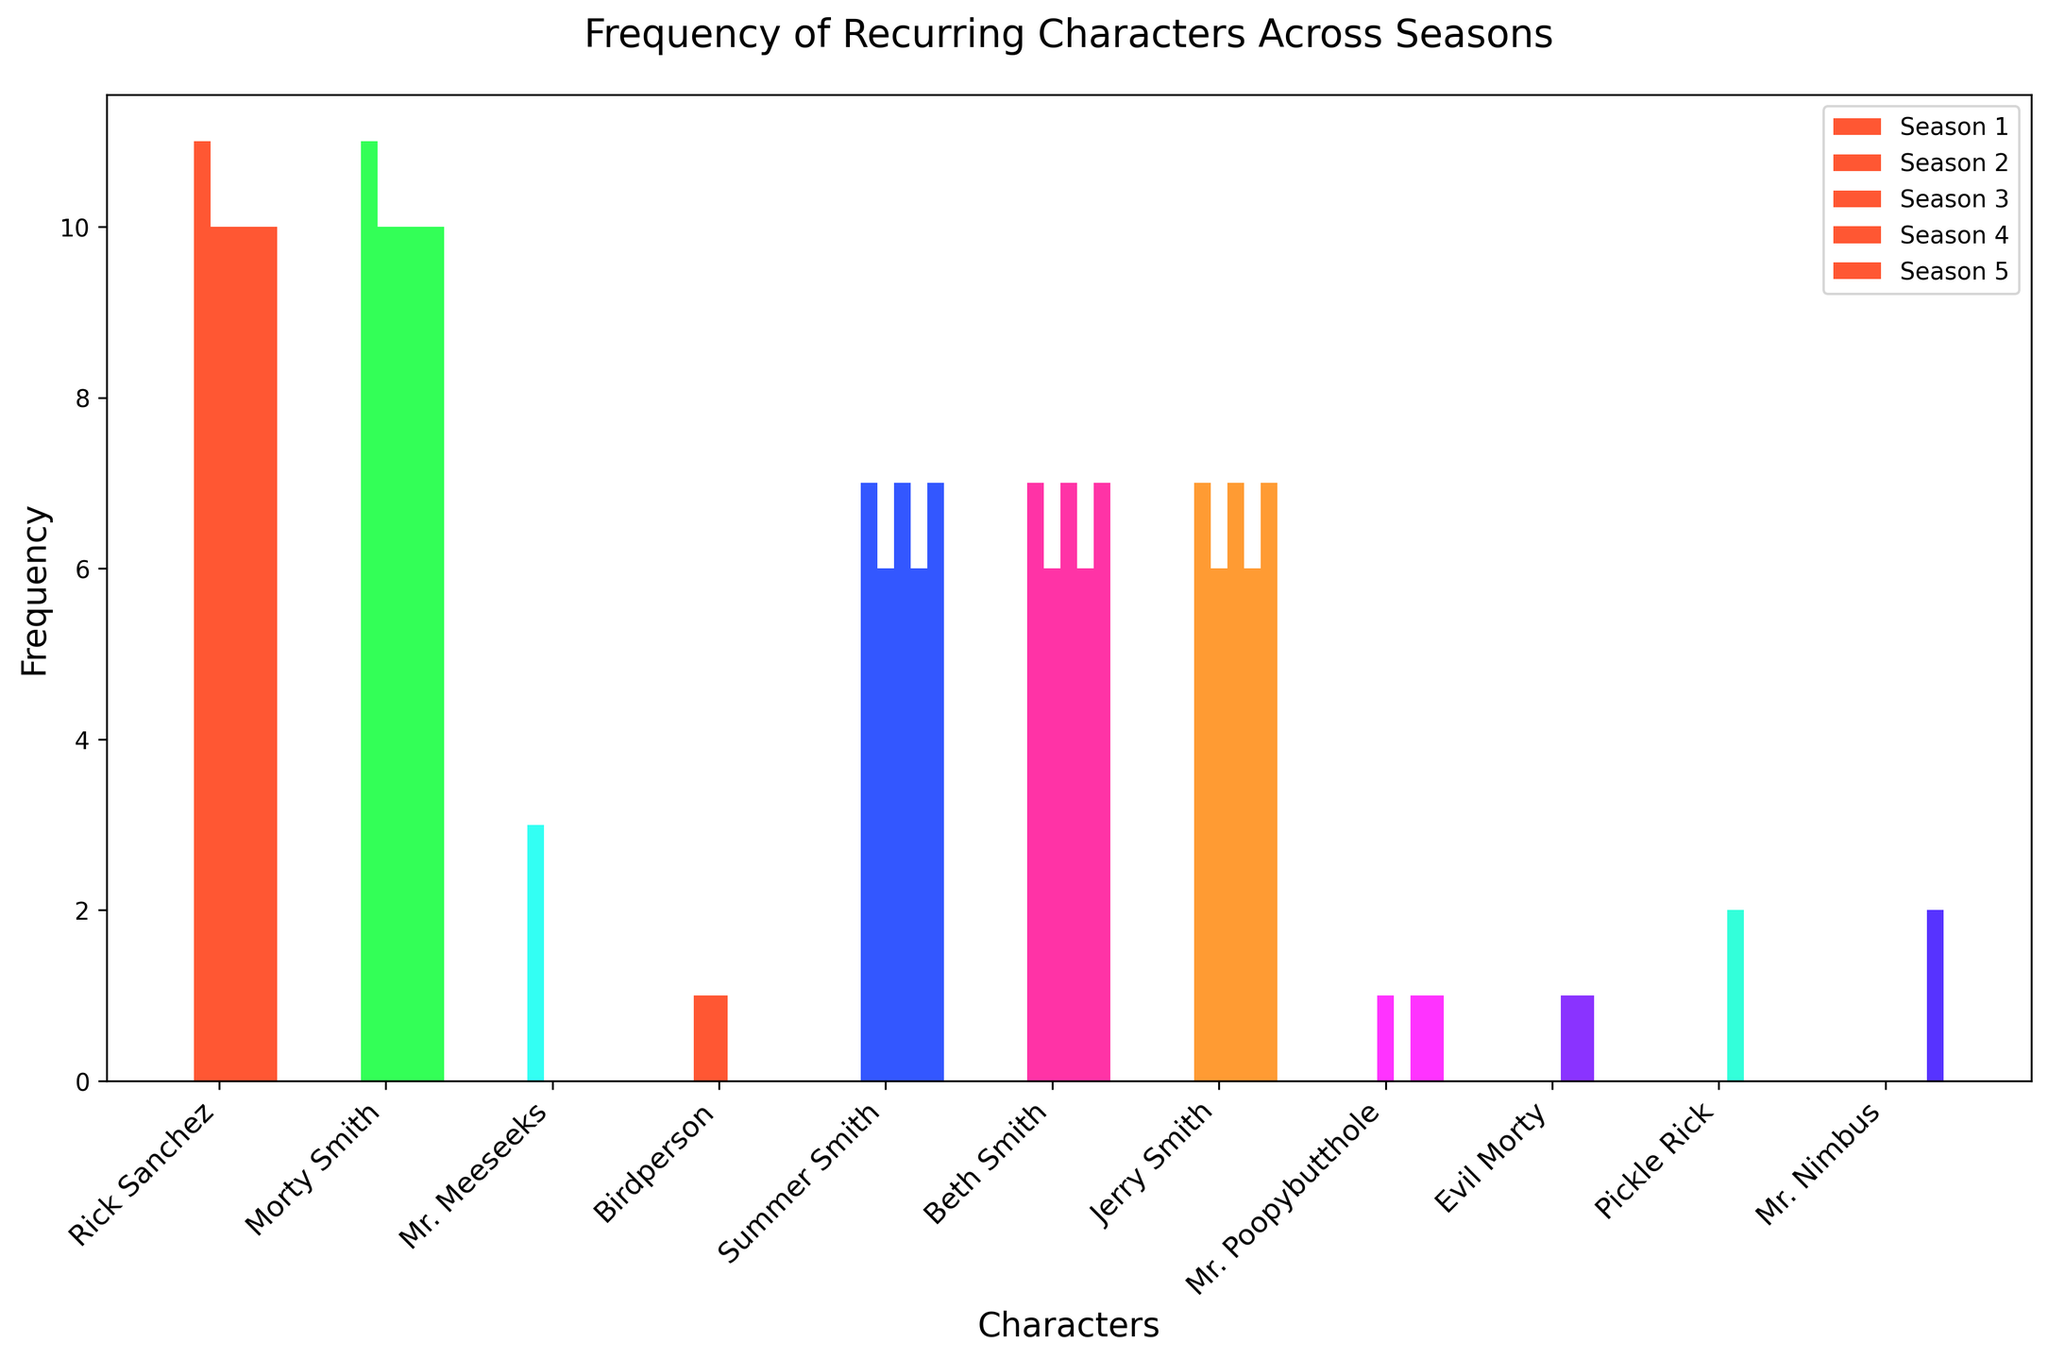Which character appears the most frequently in Season 3? Observe the heights of the bars representing each character in Season 3. The tallest bar shows "Rick Sanchez" and "Morty Smith" as the characters with the highest frequency.
Answer: Rick Sanchez and Morty Smith Who appears more frequently in Season 4, Summer Smith or Jerry Smith? Compare the bars for Summer Smith and Jerry Smith in Season 4. They have bars of the same height, indicating equal frequency.
Answer: Equal frequency What is the difference in appearance frequency between Rick Sanchez in Season 1 and Season 5? Rick Sanchez appears 11 times in Season 1 and 10 times in Season 5. Subtract 10 from 11 to find the difference.
Answer: 1 Which seasons did "Mr. Poopybutthole" appear in, and how many times in each? Identify the bars labeled "Mr. Poopybutthole" and observe their heights. He appears in Season 2 (1 time), Season 4 (1 time), and Season 5 (1 time).
Answer: Seasons 2, 4, and 5: 1 time each How many total appearances does Summer Smith have across all seasons? Sum the frequencies for Summer Smith from all seasons: 7 (S1) + 6 (S2) + 7 (S3) + 6 (S4) + 7 (S5).
Answer: 33 In which season does "Birdperson" have any appearances, and what is the total frequency for that season? Locate the bar for Birdperson, noting he appears only in Seasons 1 and 2 with a frequency of 1 each time.
Answer: Seasons 1 and 2: 1 time each Is there any character who appears consistently every season but less frequently than Rick Sanchez? By scanning across seasons, note that Morty Smith appears consistently every season but similarly in frequency to Rick Sanchez. Therefore, reevaluate for consistently occurring characters. Summer Smith, Beth Smith, and Jerry Smith appear in every season but display a frequency less than Rick Sanchez in each.
Answer: Morty Smith (equal frequency) Which season had the lowest frequency of appearances for "Beth Smith"? Compare the heights of the bars for Beth Smith across all seasons. Season 2 and Season 4 both recorded the lowest count (6 times each).
Answer: Season 2 and Season 4 Excluding the Smith family members, which character has the highest number of total appearances, and what is that number? Sum the frequencies for non-Smith characters across all seasons. Mr. Meeseeks (3), Birdperson (2), Mr. Poopybutthole (3), Evil Morty (2), Pickle Rick (2), and Mr. Nimbus (2). "Mr. Meeseeks" has the highest frequency.
Answer: Mr. Meeseeks: 3 Among recurring characters in more than one season, which character shows the greatest variation in frequency across seasons, and what is the difference? Calculate the difference in frequency for recurring characters across seasons. Rick Sanchez and Morty Smith's frequencies vary slightly, the greatest observed difference will be among Smith family members or others like Mr. Poopybutthole. Jerry Smith ranges from 6 to 7. Birdperson's appearance varies from 0 in most seasons to 1. Calculating this, the highest variance is in "Birdperson."
Answer: Birdperson: 1 